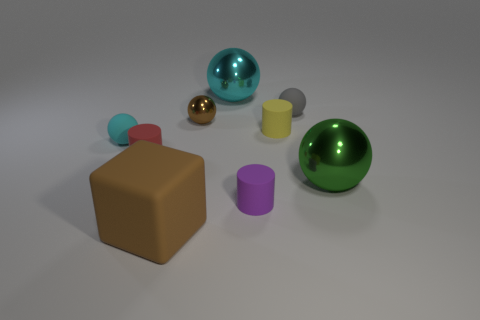There is a cyan sphere that is to the right of the brown shiny sphere; is its size the same as the small yellow cylinder?
Ensure brevity in your answer.  No. What is the shape of the small rubber thing that is in front of the tiny shiny object and on the right side of the purple matte cylinder?
Keep it short and to the point. Cylinder. Are there more yellow things right of the tiny cyan thing than small purple matte spheres?
Offer a terse response. Yes. There is a cyan sphere that is made of the same material as the gray object; what is its size?
Make the answer very short. Small. How many large rubber cubes are the same color as the small metallic object?
Make the answer very short. 1. Is the color of the big thing on the left side of the brown metallic ball the same as the small shiny thing?
Keep it short and to the point. Yes. Are there an equal number of tiny balls in front of the purple matte thing and green spheres in front of the large brown object?
Provide a short and direct response. Yes. Is there anything else that is made of the same material as the tiny purple thing?
Offer a very short reply. Yes. There is a thing in front of the tiny purple cylinder; what is its color?
Your response must be concise. Brown. Is the number of tiny gray objects that are in front of the yellow cylinder the same as the number of red rubber cylinders?
Offer a terse response. No. 